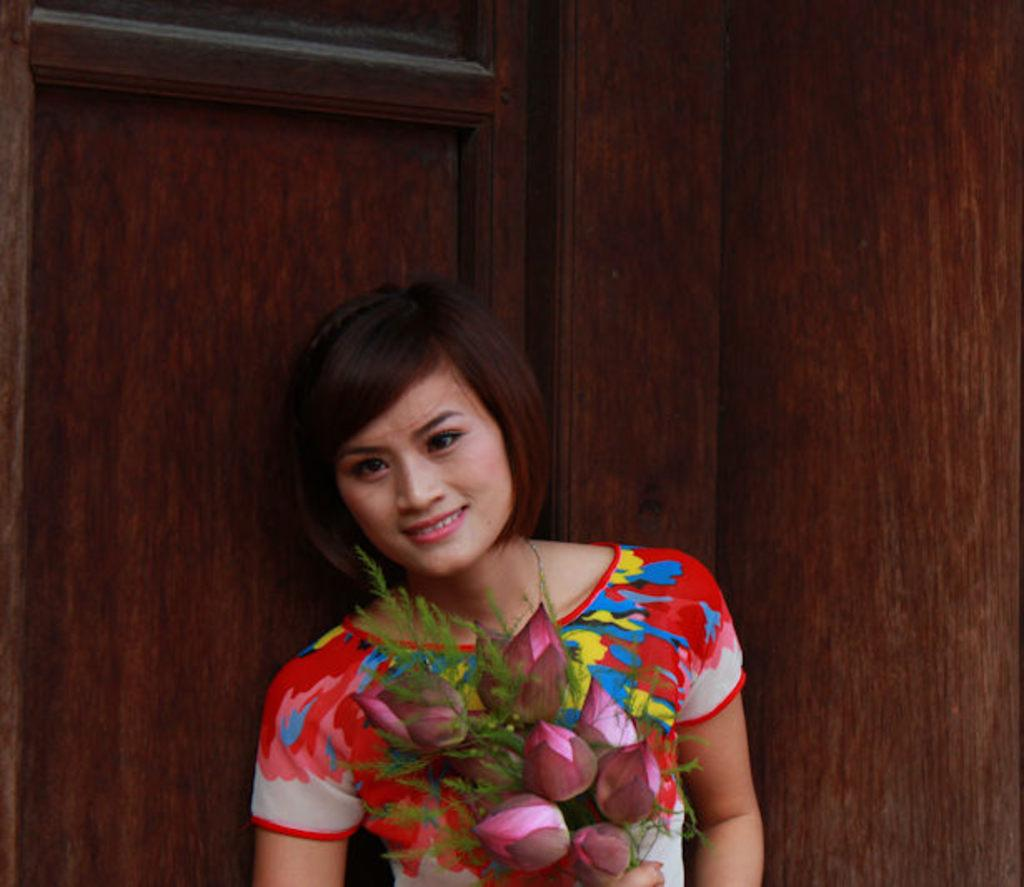Who is present in the image? There is a person in the image. What is the person holding in the image? The person is standing with a bouquet. What is the person wearing in the image? The person is wearing a colorful dress. What can be seen in the background of the image? There is a brown color object in the background of the image. What is the purpose of the ghost in the image? There is no ghost present in the image. 